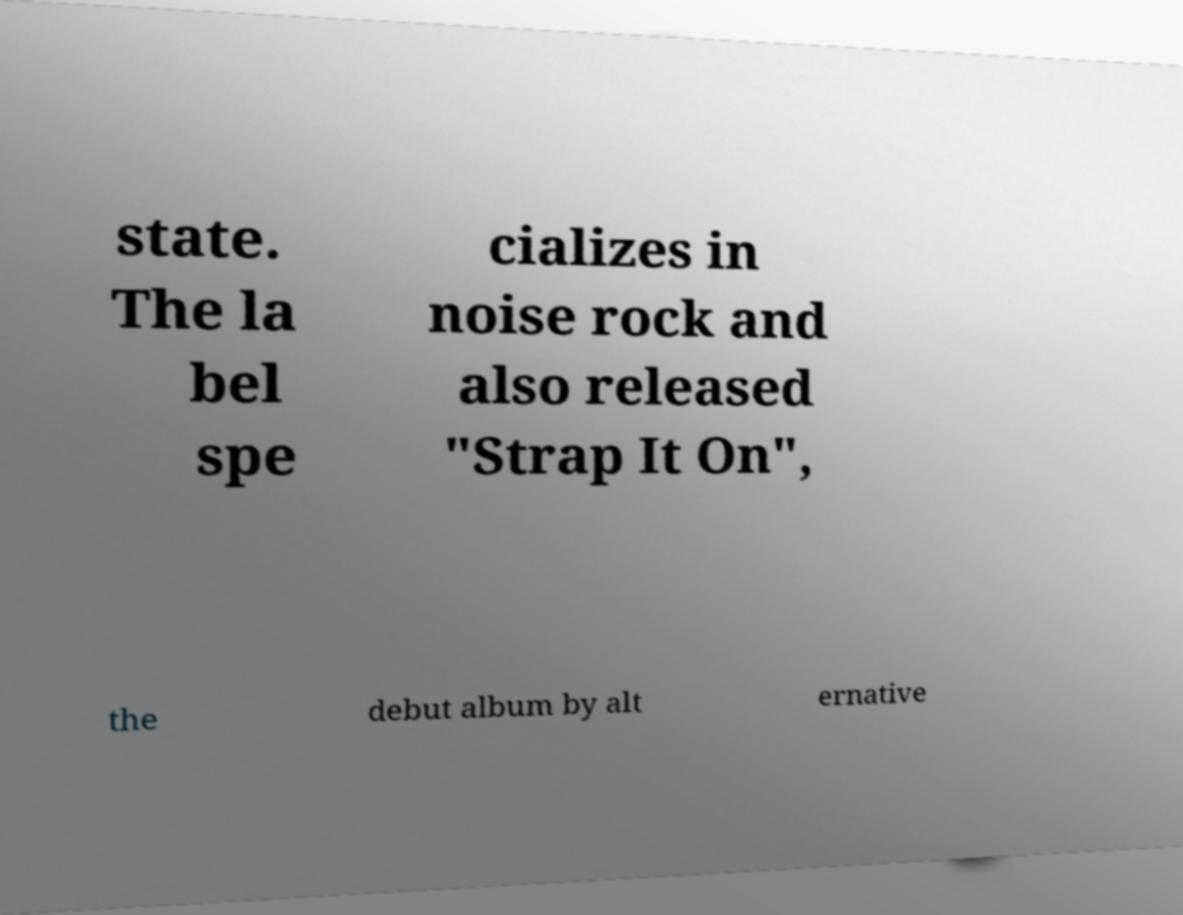I need the written content from this picture converted into text. Can you do that? state. The la bel spe cializes in noise rock and also released "Strap It On", the debut album by alt ernative 